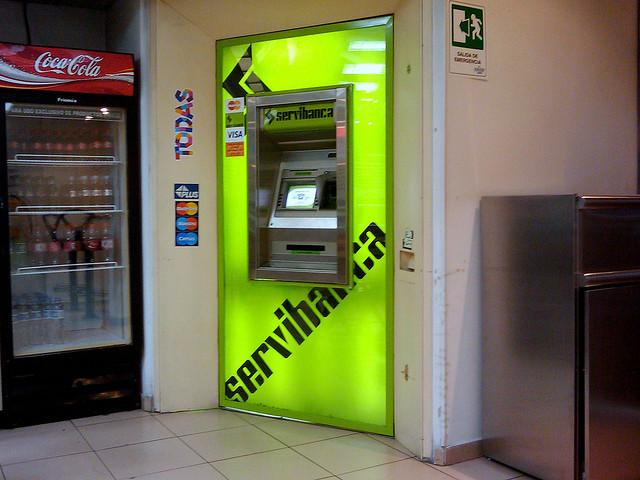What language is on the ATM?
Keep it brief. Spanish. What color is the machine?
Give a very brief answer. Green. What brand of soda is sold in the fridge?
Answer briefly. Coca cola. How many shelves are in the fridge?
Concise answer only. 4. Is the machine located inside or outside?
Write a very short answer. Inside. 